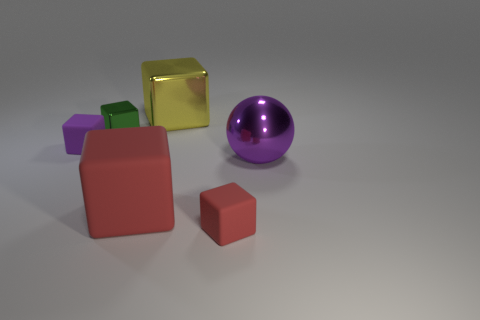Add 2 yellow metal blocks. How many objects exist? 8 Subtract all big blocks. How many blocks are left? 3 Subtract 5 blocks. How many blocks are left? 0 Subtract all purple blocks. How many blocks are left? 4 Subtract all blocks. How many objects are left? 1 Subtract all green balls. Subtract all gray cubes. How many balls are left? 1 Subtract all yellow cubes. How many gray balls are left? 0 Subtract all purple matte things. Subtract all small gray rubber cylinders. How many objects are left? 5 Add 6 tiny red cubes. How many tiny red cubes are left? 7 Add 6 large brown rubber cylinders. How many large brown rubber cylinders exist? 6 